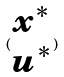<formula> <loc_0><loc_0><loc_500><loc_500>( \begin{matrix} x ^ { * } \\ u ^ { * } \end{matrix} )</formula> 